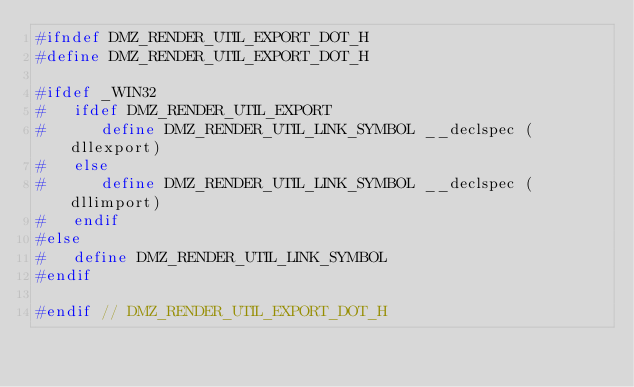<code> <loc_0><loc_0><loc_500><loc_500><_C_>#ifndef DMZ_RENDER_UTIL_EXPORT_DOT_H
#define DMZ_RENDER_UTIL_EXPORT_DOT_H

#ifdef _WIN32
#   ifdef DMZ_RENDER_UTIL_EXPORT
#      define DMZ_RENDER_UTIL_LINK_SYMBOL __declspec (dllexport)
#   else
#      define DMZ_RENDER_UTIL_LINK_SYMBOL __declspec (dllimport)
#   endif
#else
#   define DMZ_RENDER_UTIL_LINK_SYMBOL
#endif

#endif // DMZ_RENDER_UTIL_EXPORT_DOT_H
</code> 